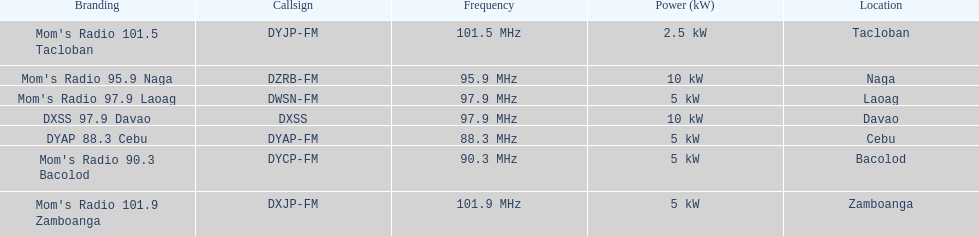What is the only radio station with a frequency below 90 mhz? DYAP 88.3 Cebu. 